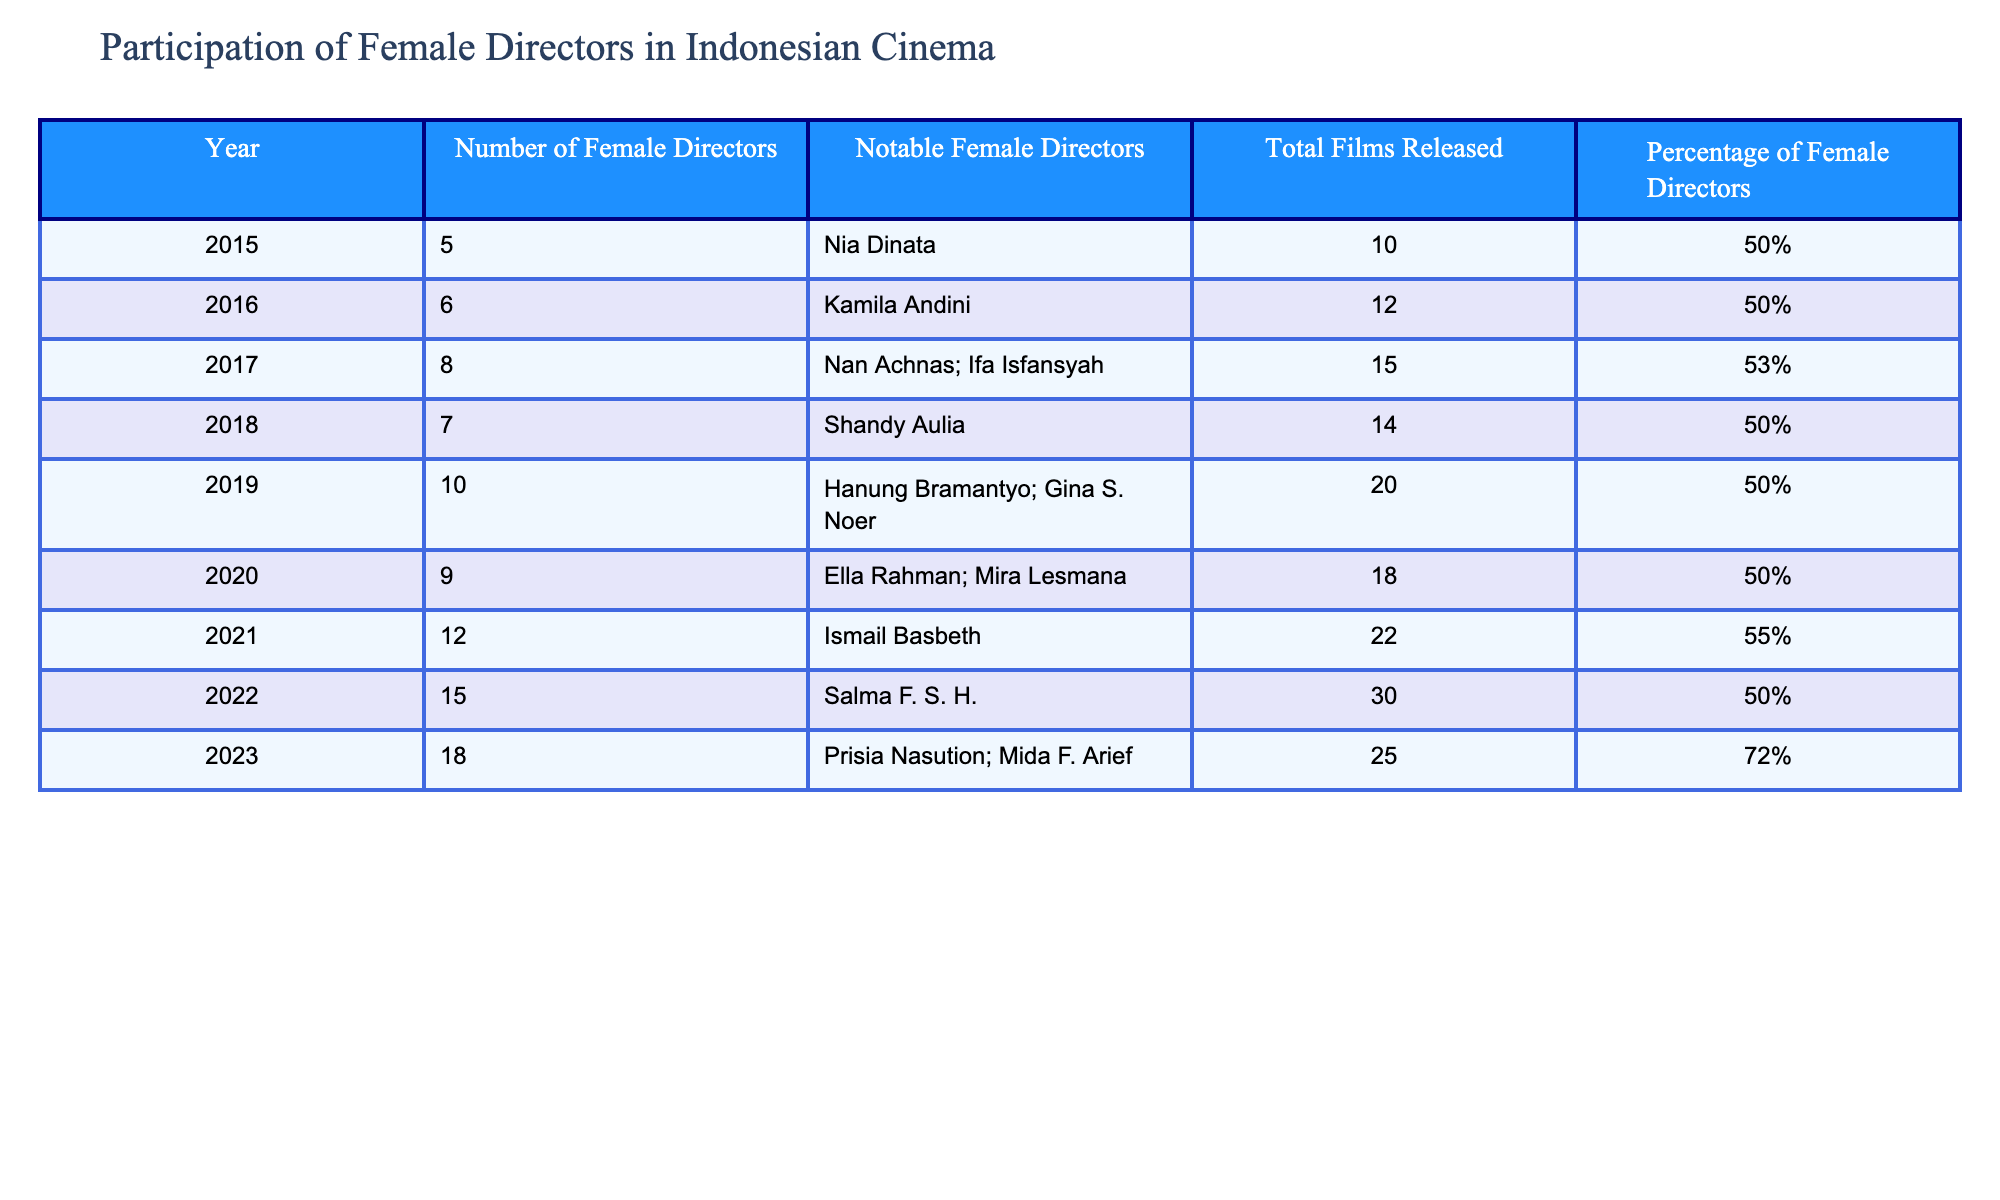What was the highest number of female directors in a single year? The highest number of female directors listed in the table is 18, which occurred in the year 2023.
Answer: 18 In which year did the percentage of female directors exceed 70%? The percentage exceeded 70% in 2023, where it was recorded as 72%.
Answer: 2023 How many total films were released in 2021? Referring to the table, there were 22 films released in 2021.
Answer: 22 What is the average percentage of female directors from 2015 to 2020? First, we identify the percentages from 2015 to 2020: 50%, 50%, 53%, 50%, 50%, 50%. Next, sum them up: 50 + 50 + 53 + 50 + 50 + 50 = 303. Then, divide by the number of years (6): 303 / 6 = 50.5%.
Answer: 50.5% Did the number of female directors increase every year from 2015 to 2023? Analyzing the data, the number of female directors increased year by year with values being 5, 6, 8, 7 (which is a decrease), 10, 9 (again a decrease), 12, 15, and 18, showing that it did not consistently increase.
Answer: No Which year had the most notable female directors listed, and who were they? In 2023, the most notable female directors listed were Prisia Nasution and Mida F. Arief.
Answer: 2023, Prisia Nasution; Mida F. Arief How many more female directors were there in 2022 compared to 2015? In 2022, there were 15 female directors, and in 2015, there were 5. The difference is found by subtracting the two: 15 - 5 = 10.
Answer: 10 What was the trend in the number of female directors from 2015 to 2023? By examining the data, the trend shows an overall increase in the number of female directors, with some fluctuations (decreases in 2018 and 2020). However, the general trend is upward, starting from 5 in 2015 to 18 in 2023.
Answer: Overall increasing trend 